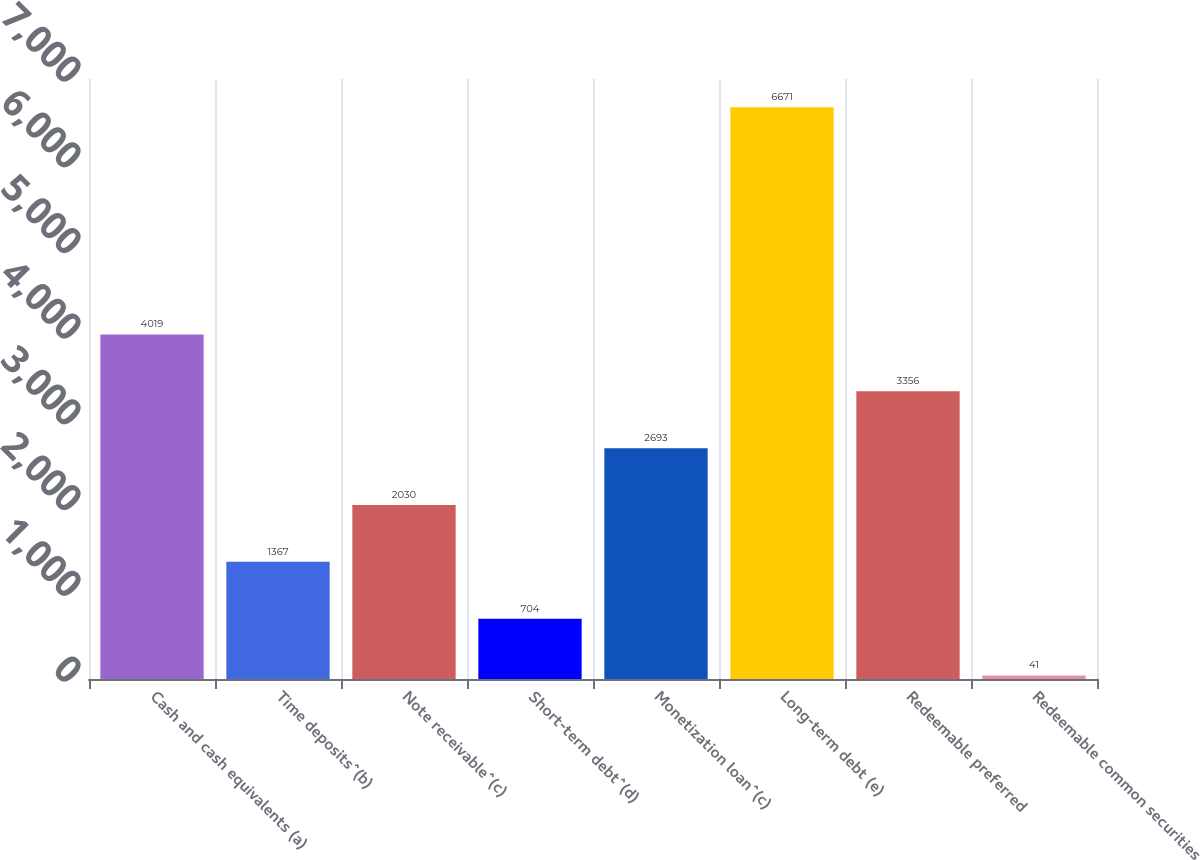<chart> <loc_0><loc_0><loc_500><loc_500><bar_chart><fcel>Cash and cash equivalents (a)<fcel>Time deposits^(b)<fcel>Note receivable^(c)<fcel>Short-term debt^(d)<fcel>Monetization loan^(c)<fcel>Long-term debt (e)<fcel>Redeemable preferred<fcel>Redeemable common securities<nl><fcel>4019<fcel>1367<fcel>2030<fcel>704<fcel>2693<fcel>6671<fcel>3356<fcel>41<nl></chart> 